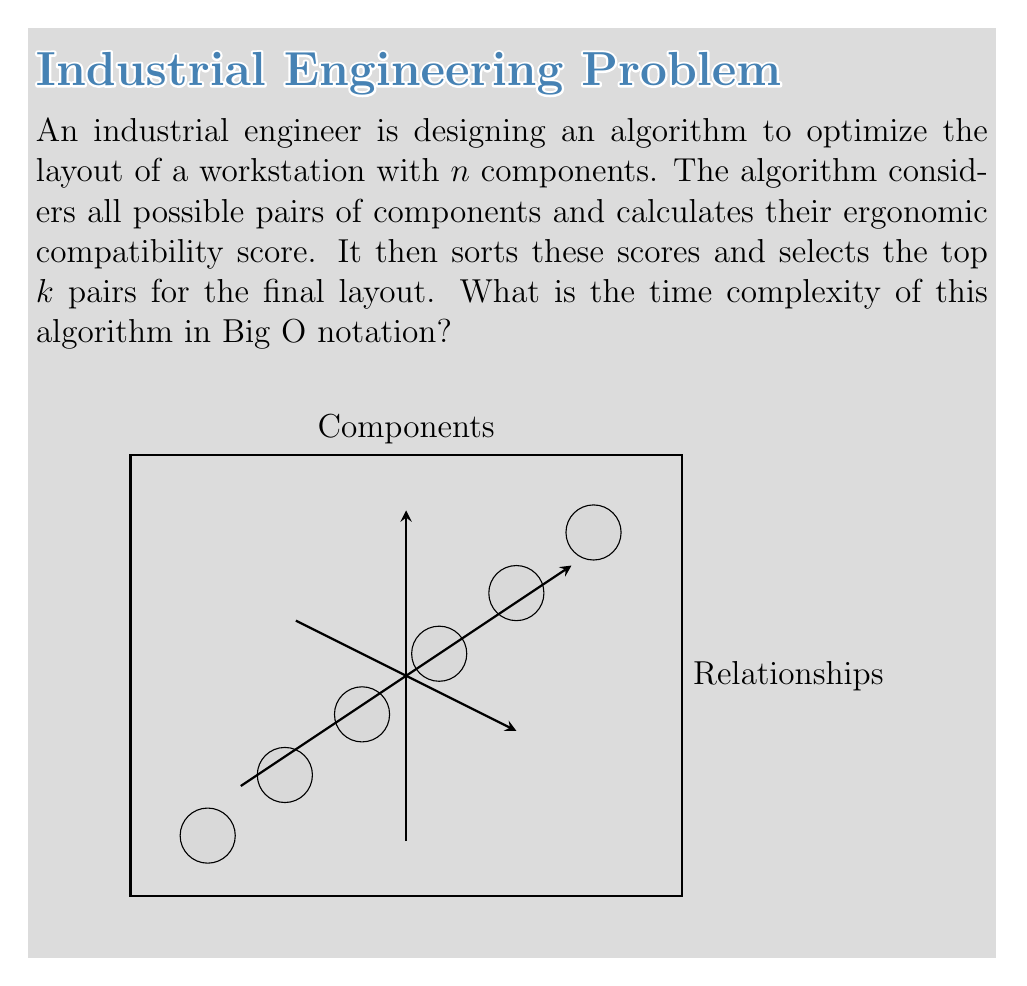Provide a solution to this math problem. Let's break down the algorithm and analyze its time complexity step by step:

1. Considering all possible pairs of components:
   - With $n$ components, there are $\binom{n}{2} = \frac{n(n-1)}{2}$ pairs.
   - This step has a time complexity of $O(n^2)$.

2. Calculating ergonomic compatibility scores:
   - Assuming the calculation for each pair takes constant time.
   - This step also has a time complexity of $O(n^2)$.

3. Sorting the compatibility scores:
   - There are $\frac{n(n-1)}{2}$ scores to sort.
   - Using an efficient sorting algorithm like Merge Sort or Heap Sort, this step has a time complexity of $O(n^2 \log n)$.

4. Selecting the top $k$ pairs:
   - This can be done in linear time with respect to the number of pairs, so it's $O(n^2)$.

The overall time complexity is determined by the most time-consuming step, which is the sorting operation. Therefore, the time complexity of the entire algorithm is $O(n^2 \log n)$.

Note: Even if $k$ is significantly smaller than $n^2$, it doesn't affect the overall time complexity because the algorithm still needs to sort all pairs to find the top $k$.
Answer: $O(n^2 \log n)$ 